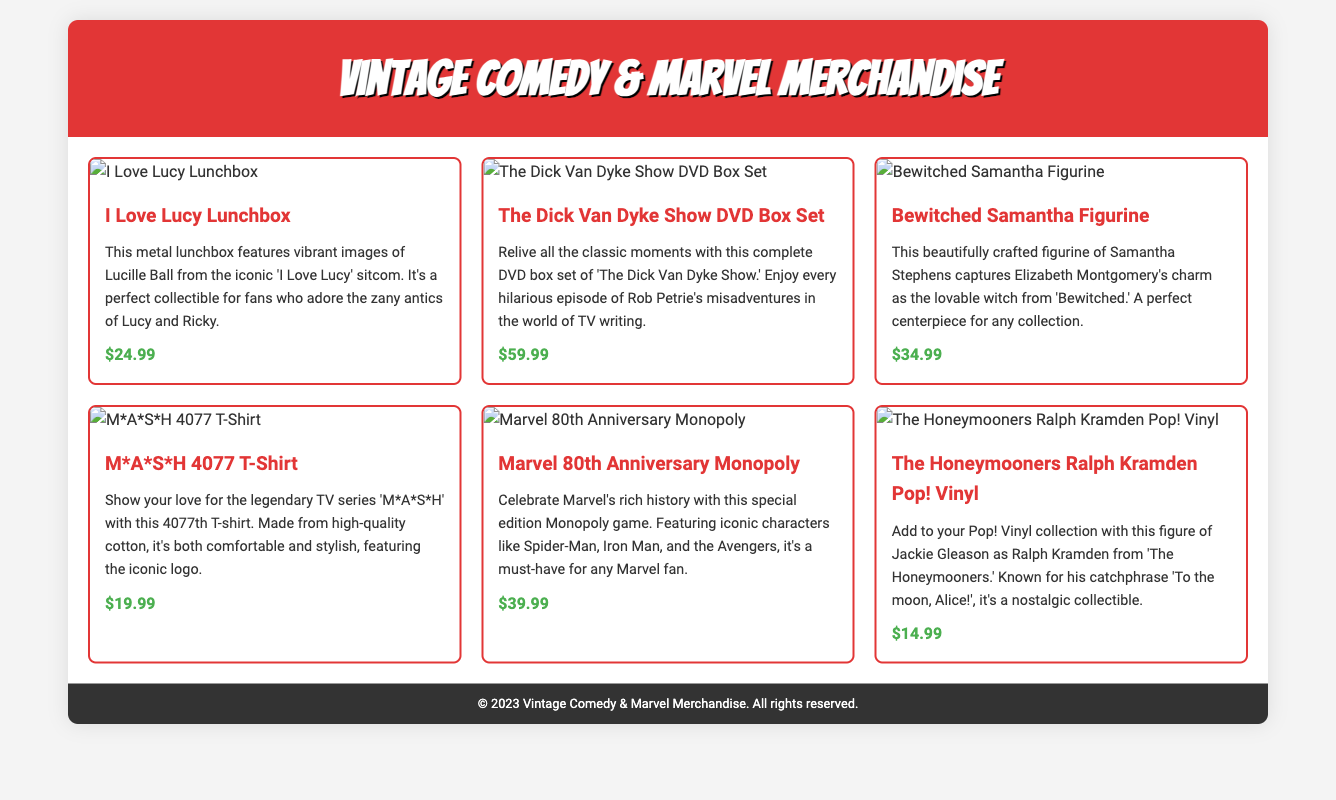What is the title of the first product listed? The title of the first product is found in the product card at the beginning of the main section.
Answer: I Love Lucy Lunchbox What is the price of the M*A*S*H 4077 T-Shirt? The price is displayed in the product information for the corresponding product card.
Answer: $19.99 How many items are available in this catalog? The total number of product cards in the main section indicates how many items are presented.
Answer: 6 Which show's DVD box set is featured? The specific title and description of the DVD box set clarify which show it represents.
Answer: The Dick Van Dyke Show What is the theme of the Monopoly game? The description of the product specifically mentions the occasion for this edition of the game.
Answer: Marvel's rich history Who is the character featured in the Pop! Vinyl figure? The product description indicates the character and show from which the figure originates.
Answer: Ralph Kramden Which item is categorized as a figurine? The distinction can be made by looking at the specific titles and descriptions associated with the item.
Answer: Bewitched Samantha Figurine 